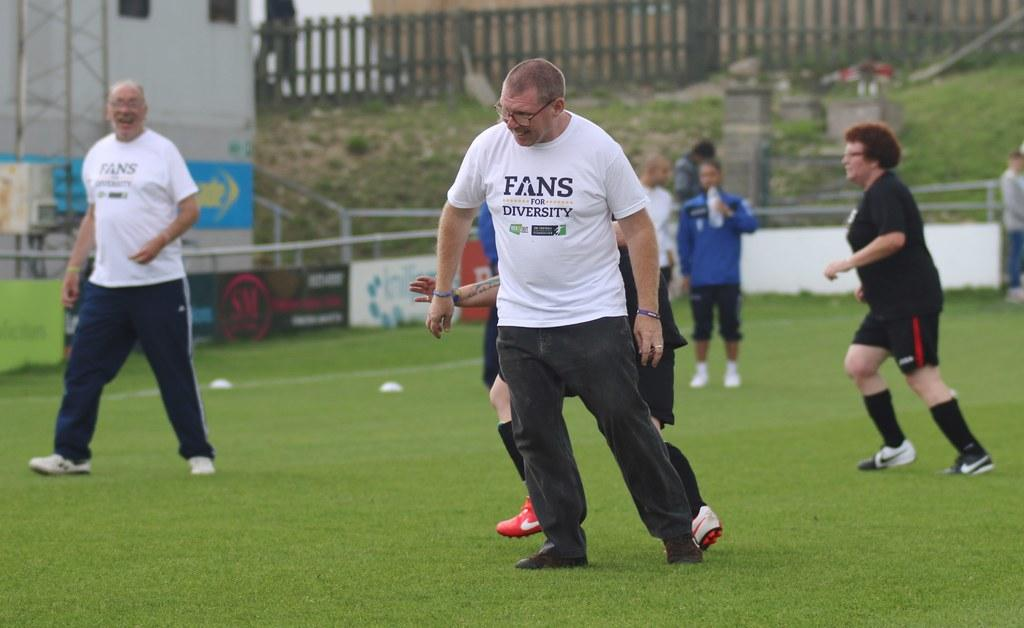<image>
Write a terse but informative summary of the picture. A man is wearing a white t-shirt that says "fans for diversity" 